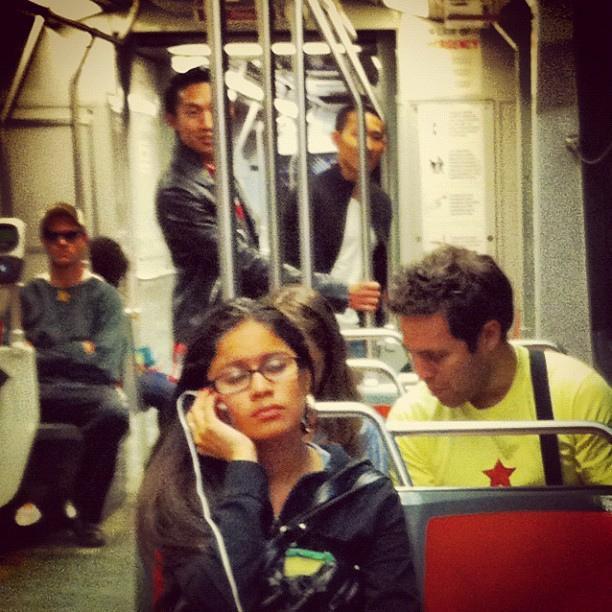The shape the man has on his yellow shirt is found on what flag?
Make your selection from the four choices given to correctly answer the question.
Options: China, argentina, greece, sweden. China. 